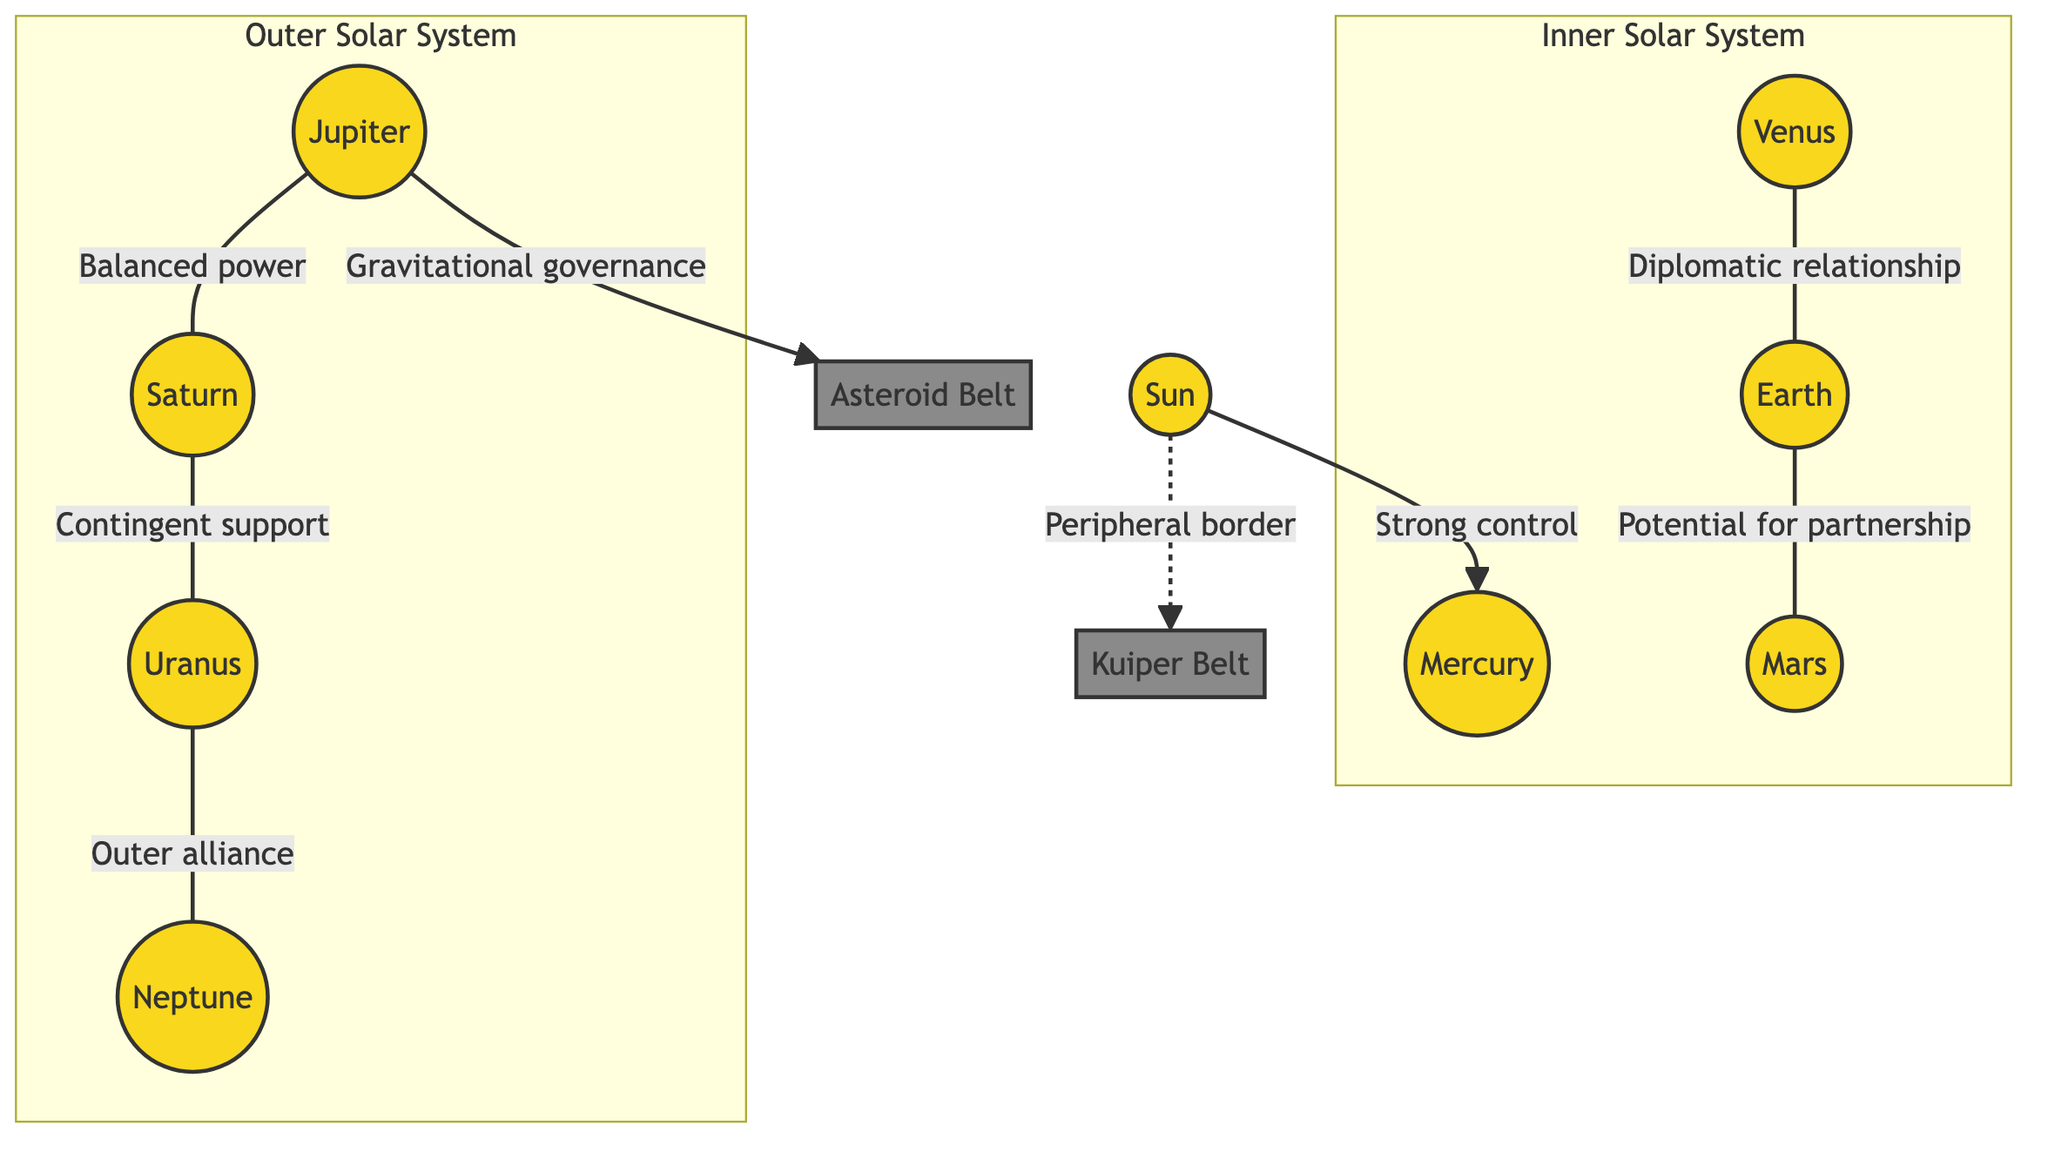What is the central node in the diagram? The central node in the diagram is the Sun, which is at the core of the solar system and the primary gravitational force influencing the other celestial bodies.
Answer: Sun How many planets are illustrated in the inner solar system? The inner solar system includes four planets: Mercury, Venus, Earth, and Mars, which are explicitly shown within the subgraph labeled Inner Solar System.
Answer: 4 What relationship is indicated between Jupiter and Saturn? The relationship indicated between Jupiter and Saturn is 'Balanced power', which suggests an equilibrium or cooperative dynamic between these two large planets.
Answer: Balanced power Which belt is governed by Jupiter's gravitational force? Jupiter has gravitational governance over the Asteroid Belt, as shown by the directional arrow linking them, indicating Jupiter’s influence in that area.
Answer: Asteroid Belt What type of relationship exists between Venus and Earth? The relationship between Venus and Earth is described as a 'Diplomatic relationship', indicating that these two planets maintain cordial and cooperative interrelations.
Answer: Diplomatic relationship What is the peripheral border around the solar system? The diagram indicates that the Kuiper Belt acts as a peripheral border, which is a distant zone at the edge of the Solar System, influenced by the Sun in a less direct manner.
Answer: Kuiper Belt How many notable asteroid belts are depicted in the diagram? There are two notable asteroid belts depicted: the Asteroid Belt and the Kuiper Belt, making up key parts of the solar system's structure.
Answer: 2 What alliance is suggested between Uranus and Neptune? The alliance suggested between Uranus and Neptune is termed 'Outer alliance', indicating a cooperative or supportive relationship between these outer planets.
Answer: Outer alliance Which planet has the strongest control over Mercury? The Sun has the strongest control over Mercury, as expressed in the diagram by a directional line labeled 'Strong control' pointing from the Sun to Mercury.
Answer: Sun 